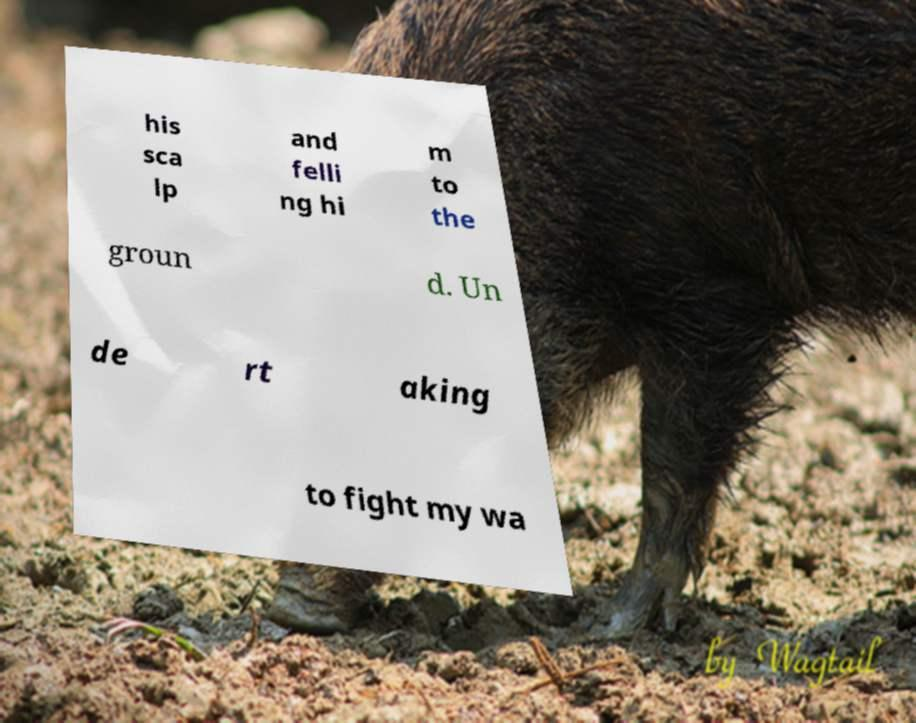There's text embedded in this image that I need extracted. Can you transcribe it verbatim? his sca lp and felli ng hi m to the groun d. Un de rt aking to fight my wa 